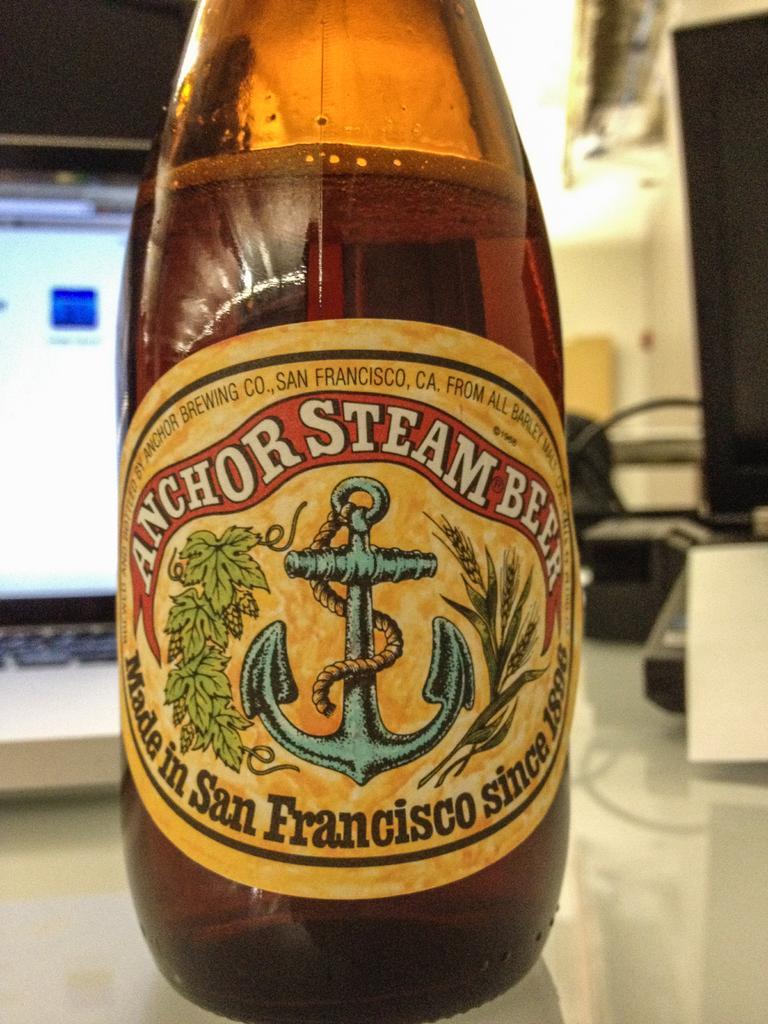In one or two sentences, can you explain what this image depicts? In this picture there is a bottle kept on the table with the name and anchor steam beer made in San Francisco since and there is a symbol on this bottle. In the background there is a screen, chair. 